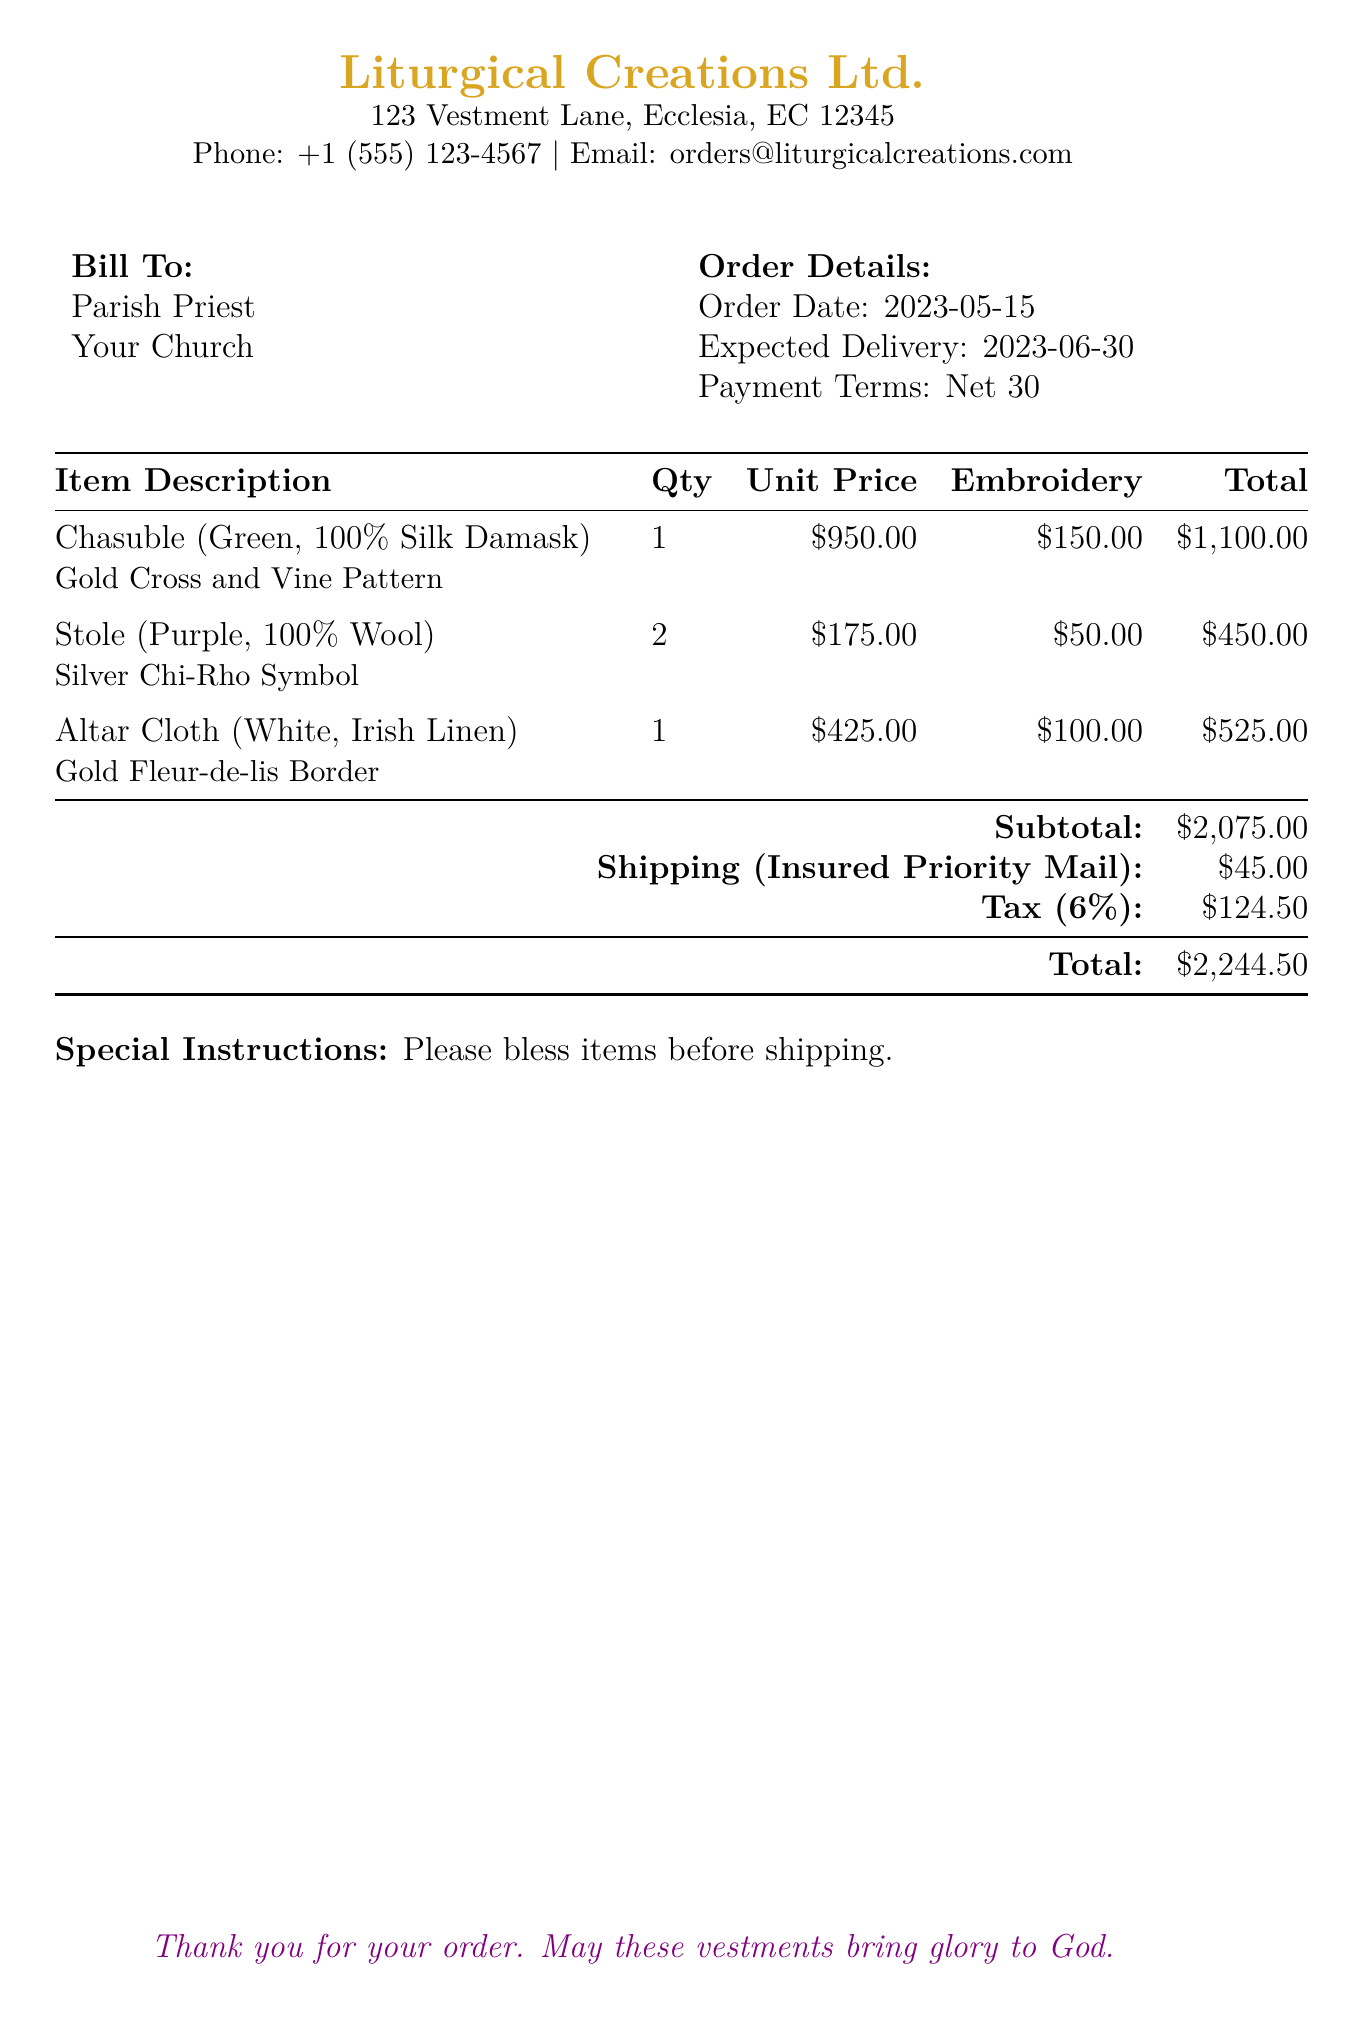what is the total amount due? The total amount due is the final amount listed in the document, which includes the subtotal, shipping, and tax.
Answer: $2,244.50 what is the expected delivery date? The expected delivery date is noted in the order details section of the document.
Answer: 2023-06-30 how many stoles were ordered? The quantity of stoles ordered is specified in the item description table.
Answer: 2 what is the unit price of the chasuble? The unit price for the chasuble is found in the item description table in the document.
Answer: $950.00 what is the subtotal before tax? The subtotal is calculated from the total of all item costs before any additional charges like shipping and tax.
Answer: $2,075.00 what specific embroidery is on the stole? The embroidery details are included alongside the description of the stole in the item table.
Answer: Silver Chi-Rho Symbol what is the tax percentage applied? The tax percentage is mentioned while calculating the total amount on the document.
Answer: 6% what are the payment terms stated in the document? The payment terms are specified clearly in the order details section of the document.
Answer: Net 30 what special instruction is included regarding the items? The special instructions provided in the document mention how the items should be treated before shipping.
Answer: Please bless items before shipping 